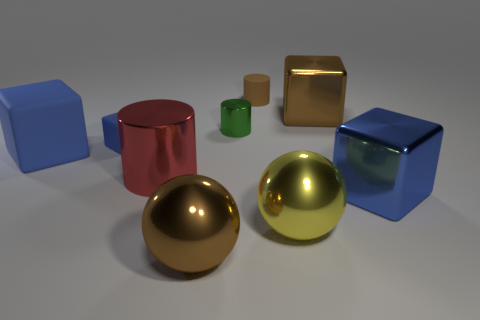How many blue blocks must be subtracted to get 1 blue blocks? 2 Subtract all purple balls. How many blue blocks are left? 3 Subtract all small blue rubber blocks. How many blocks are left? 3 Subtract all purple cubes. Subtract all blue cylinders. How many cubes are left? 4 Add 1 matte things. How many objects exist? 10 Subtract all balls. How many objects are left? 7 Subtract 0 purple spheres. How many objects are left? 9 Subtract all blue shiny cubes. Subtract all small brown rubber things. How many objects are left? 7 Add 9 brown balls. How many brown balls are left? 10 Add 2 small gray matte blocks. How many small gray matte blocks exist? 2 